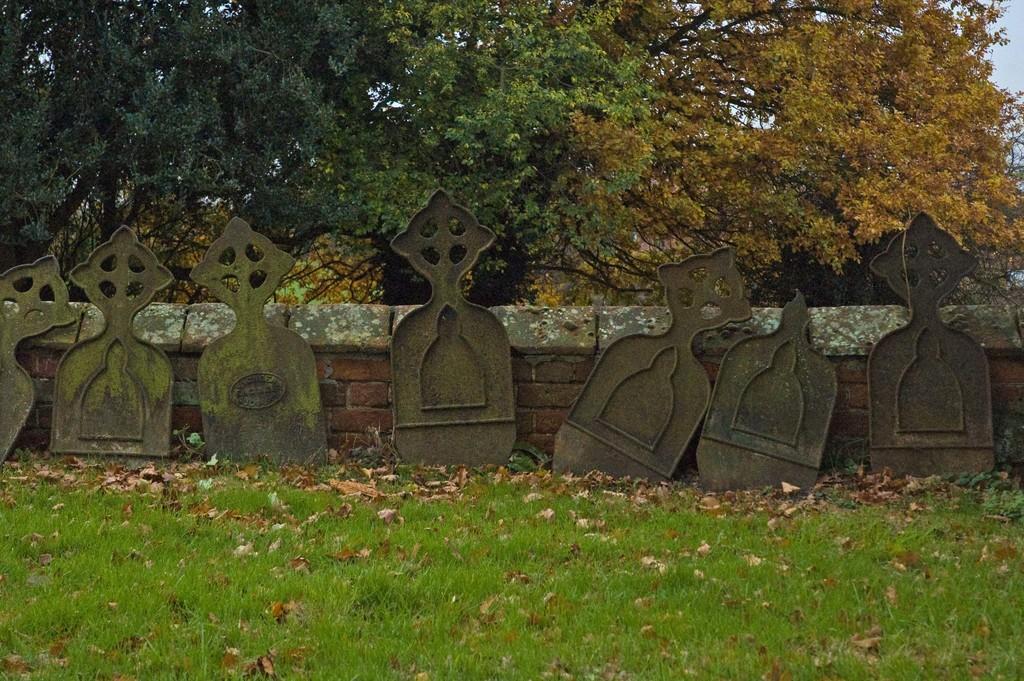Can you describe this image briefly? In this image in the center there is a wall and some metal objects, at the bottom there is grass and some dry leaves. And in the background there are trees and sky. 